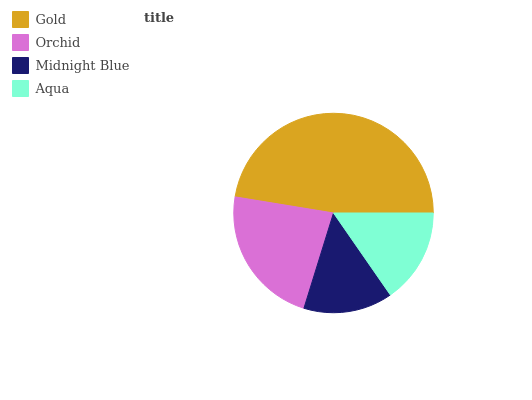Is Midnight Blue the minimum?
Answer yes or no. Yes. Is Gold the maximum?
Answer yes or no. Yes. Is Orchid the minimum?
Answer yes or no. No. Is Orchid the maximum?
Answer yes or no. No. Is Gold greater than Orchid?
Answer yes or no. Yes. Is Orchid less than Gold?
Answer yes or no. Yes. Is Orchid greater than Gold?
Answer yes or no. No. Is Gold less than Orchid?
Answer yes or no. No. Is Orchid the high median?
Answer yes or no. Yes. Is Aqua the low median?
Answer yes or no. Yes. Is Gold the high median?
Answer yes or no. No. Is Gold the low median?
Answer yes or no. No. 